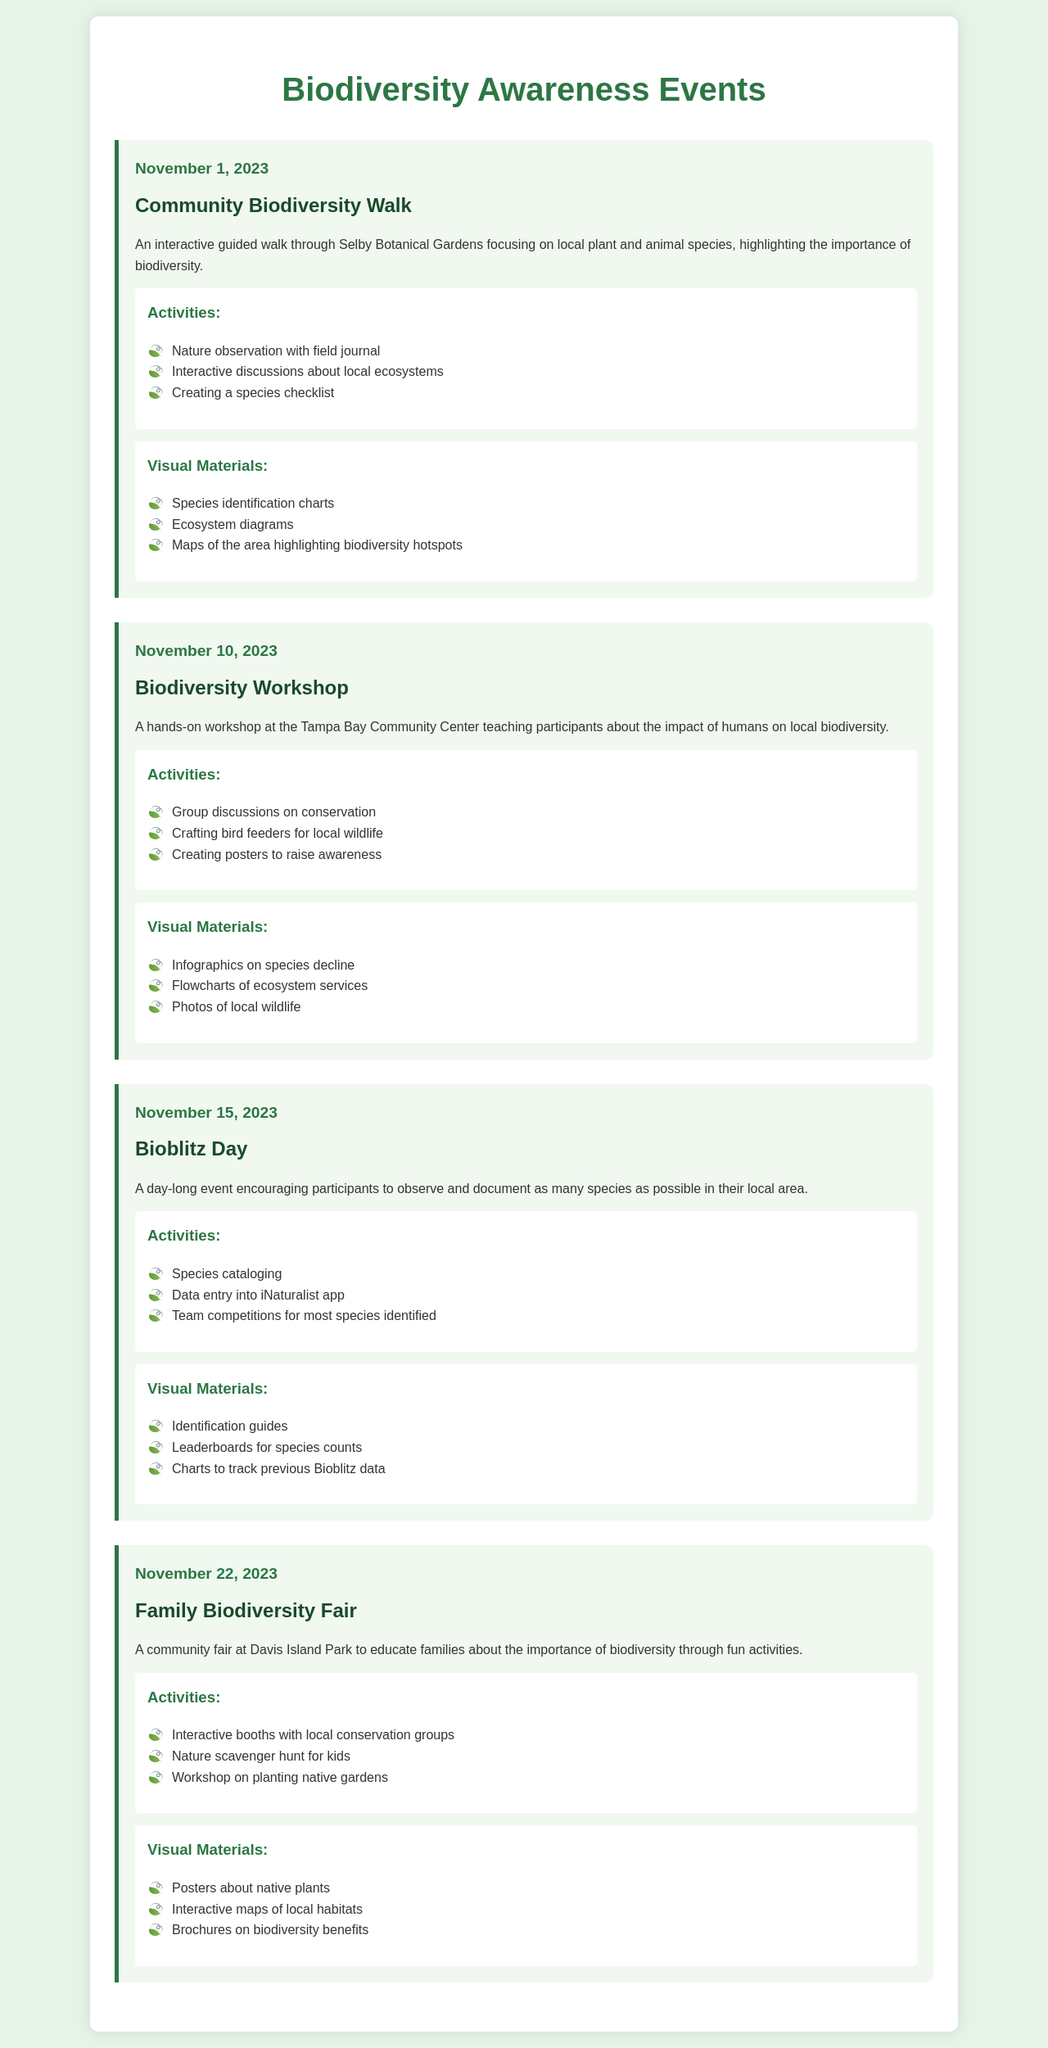What is the date of the Community Biodiversity Walk? The date is explicitly mentioned alongside the event title in the document.
Answer: November 1, 2023 What activity involves creating posters? This activity is outlined in the Biodiversity Workshop event description.
Answer: Crafting bird feeders for local wildlife What is the title of the event on November 15, 2023? The title is clearly stated in the form of an event heading in the document.
Answer: Bioblitz Day How many events are scheduled for November 2023? By counting each event listed in the document, the total number can be determined.
Answer: 4 What type of event is the Family Biodiversity Fair? The event type is indicated in the event description and title.
Answer: Community fair Which visual material is used for species identification? This is highlighted in the visual materials section under the Community Biodiversity Walk event.
Answer: Species identification charts What common activity is present in both the Community Biodiversity Walk and Bioblitz Day? This activity can be inferred by examining the activities listed for both events.
Answer: Species cataloging What important topic is covered during the Biodiversity Workshop? The main topic is mentioned in the event description of the workshop.
Answer: Impact of humans on local biodiversity 